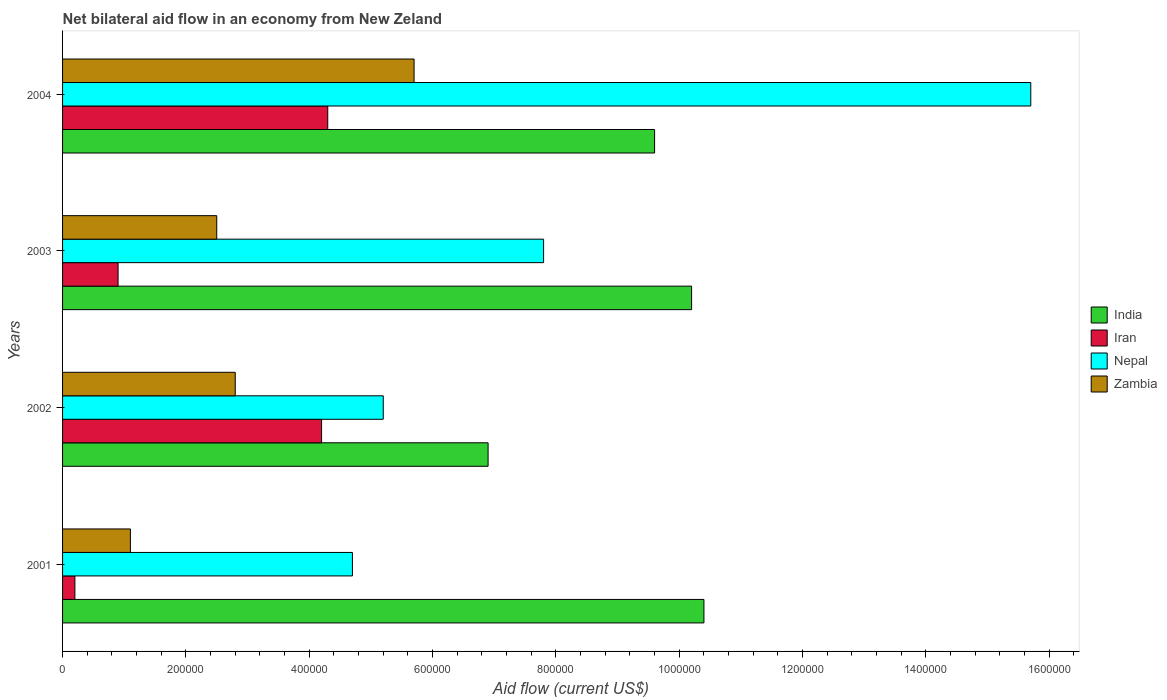Are the number of bars per tick equal to the number of legend labels?
Provide a short and direct response. Yes. In how many cases, is the number of bars for a given year not equal to the number of legend labels?
Offer a terse response. 0. What is the net bilateral aid flow in Iran in 2001?
Give a very brief answer. 2.00e+04. Across all years, what is the maximum net bilateral aid flow in Iran?
Make the answer very short. 4.30e+05. Across all years, what is the minimum net bilateral aid flow in Zambia?
Your answer should be compact. 1.10e+05. In which year was the net bilateral aid flow in Zambia maximum?
Your answer should be very brief. 2004. What is the total net bilateral aid flow in Zambia in the graph?
Keep it short and to the point. 1.21e+06. What is the difference between the net bilateral aid flow in Zambia in 2001 and the net bilateral aid flow in India in 2002?
Provide a succinct answer. -5.80e+05. What is the average net bilateral aid flow in Nepal per year?
Your answer should be very brief. 8.35e+05. In the year 2003, what is the difference between the net bilateral aid flow in Iran and net bilateral aid flow in Nepal?
Give a very brief answer. -6.90e+05. What is the ratio of the net bilateral aid flow in Nepal in 2001 to that in 2004?
Your answer should be very brief. 0.3. What is the difference between the highest and the second highest net bilateral aid flow in Zambia?
Keep it short and to the point. 2.90e+05. Is it the case that in every year, the sum of the net bilateral aid flow in India and net bilateral aid flow in Zambia is greater than the sum of net bilateral aid flow in Nepal and net bilateral aid flow in Iran?
Offer a terse response. No. What does the 3rd bar from the top in 2002 represents?
Your response must be concise. Iran. How many years are there in the graph?
Provide a succinct answer. 4. Where does the legend appear in the graph?
Ensure brevity in your answer.  Center right. How many legend labels are there?
Provide a succinct answer. 4. What is the title of the graph?
Offer a very short reply. Net bilateral aid flow in an economy from New Zeland. What is the label or title of the X-axis?
Your response must be concise. Aid flow (current US$). What is the label or title of the Y-axis?
Make the answer very short. Years. What is the Aid flow (current US$) of India in 2001?
Your answer should be very brief. 1.04e+06. What is the Aid flow (current US$) in Iran in 2001?
Provide a short and direct response. 2.00e+04. What is the Aid flow (current US$) in India in 2002?
Keep it short and to the point. 6.90e+05. What is the Aid flow (current US$) of Iran in 2002?
Offer a very short reply. 4.20e+05. What is the Aid flow (current US$) of Nepal in 2002?
Your answer should be very brief. 5.20e+05. What is the Aid flow (current US$) in Zambia in 2002?
Make the answer very short. 2.80e+05. What is the Aid flow (current US$) in India in 2003?
Make the answer very short. 1.02e+06. What is the Aid flow (current US$) of Nepal in 2003?
Give a very brief answer. 7.80e+05. What is the Aid flow (current US$) in Zambia in 2003?
Provide a short and direct response. 2.50e+05. What is the Aid flow (current US$) of India in 2004?
Your answer should be very brief. 9.60e+05. What is the Aid flow (current US$) of Iran in 2004?
Your answer should be very brief. 4.30e+05. What is the Aid flow (current US$) in Nepal in 2004?
Provide a short and direct response. 1.57e+06. What is the Aid flow (current US$) of Zambia in 2004?
Offer a terse response. 5.70e+05. Across all years, what is the maximum Aid flow (current US$) of India?
Make the answer very short. 1.04e+06. Across all years, what is the maximum Aid flow (current US$) in Iran?
Provide a short and direct response. 4.30e+05. Across all years, what is the maximum Aid flow (current US$) in Nepal?
Offer a terse response. 1.57e+06. Across all years, what is the maximum Aid flow (current US$) of Zambia?
Offer a terse response. 5.70e+05. Across all years, what is the minimum Aid flow (current US$) of India?
Ensure brevity in your answer.  6.90e+05. Across all years, what is the minimum Aid flow (current US$) of Iran?
Keep it short and to the point. 2.00e+04. Across all years, what is the minimum Aid flow (current US$) in Zambia?
Keep it short and to the point. 1.10e+05. What is the total Aid flow (current US$) of India in the graph?
Make the answer very short. 3.71e+06. What is the total Aid flow (current US$) in Iran in the graph?
Provide a short and direct response. 9.60e+05. What is the total Aid flow (current US$) in Nepal in the graph?
Your response must be concise. 3.34e+06. What is the total Aid flow (current US$) of Zambia in the graph?
Provide a short and direct response. 1.21e+06. What is the difference between the Aid flow (current US$) of India in 2001 and that in 2002?
Your response must be concise. 3.50e+05. What is the difference between the Aid flow (current US$) of Iran in 2001 and that in 2002?
Your answer should be very brief. -4.00e+05. What is the difference between the Aid flow (current US$) of Nepal in 2001 and that in 2002?
Offer a terse response. -5.00e+04. What is the difference between the Aid flow (current US$) of India in 2001 and that in 2003?
Ensure brevity in your answer.  2.00e+04. What is the difference between the Aid flow (current US$) in Nepal in 2001 and that in 2003?
Give a very brief answer. -3.10e+05. What is the difference between the Aid flow (current US$) of Iran in 2001 and that in 2004?
Provide a short and direct response. -4.10e+05. What is the difference between the Aid flow (current US$) in Nepal in 2001 and that in 2004?
Provide a short and direct response. -1.10e+06. What is the difference between the Aid flow (current US$) of Zambia in 2001 and that in 2004?
Your response must be concise. -4.60e+05. What is the difference between the Aid flow (current US$) in India in 2002 and that in 2003?
Give a very brief answer. -3.30e+05. What is the difference between the Aid flow (current US$) in Iran in 2002 and that in 2003?
Your answer should be very brief. 3.30e+05. What is the difference between the Aid flow (current US$) in Zambia in 2002 and that in 2003?
Keep it short and to the point. 3.00e+04. What is the difference between the Aid flow (current US$) in India in 2002 and that in 2004?
Your response must be concise. -2.70e+05. What is the difference between the Aid flow (current US$) in Nepal in 2002 and that in 2004?
Make the answer very short. -1.05e+06. What is the difference between the Aid flow (current US$) in Iran in 2003 and that in 2004?
Your answer should be compact. -3.40e+05. What is the difference between the Aid flow (current US$) of Nepal in 2003 and that in 2004?
Your response must be concise. -7.90e+05. What is the difference between the Aid flow (current US$) in Zambia in 2003 and that in 2004?
Your answer should be very brief. -3.20e+05. What is the difference between the Aid flow (current US$) of India in 2001 and the Aid flow (current US$) of Iran in 2002?
Offer a very short reply. 6.20e+05. What is the difference between the Aid flow (current US$) of India in 2001 and the Aid flow (current US$) of Nepal in 2002?
Offer a very short reply. 5.20e+05. What is the difference between the Aid flow (current US$) in India in 2001 and the Aid flow (current US$) in Zambia in 2002?
Your answer should be compact. 7.60e+05. What is the difference between the Aid flow (current US$) in Iran in 2001 and the Aid flow (current US$) in Nepal in 2002?
Make the answer very short. -5.00e+05. What is the difference between the Aid flow (current US$) in Iran in 2001 and the Aid flow (current US$) in Zambia in 2002?
Your answer should be very brief. -2.60e+05. What is the difference between the Aid flow (current US$) of India in 2001 and the Aid flow (current US$) of Iran in 2003?
Offer a very short reply. 9.50e+05. What is the difference between the Aid flow (current US$) of India in 2001 and the Aid flow (current US$) of Nepal in 2003?
Your response must be concise. 2.60e+05. What is the difference between the Aid flow (current US$) in India in 2001 and the Aid flow (current US$) in Zambia in 2003?
Your response must be concise. 7.90e+05. What is the difference between the Aid flow (current US$) of Iran in 2001 and the Aid flow (current US$) of Nepal in 2003?
Provide a short and direct response. -7.60e+05. What is the difference between the Aid flow (current US$) of Iran in 2001 and the Aid flow (current US$) of Zambia in 2003?
Make the answer very short. -2.30e+05. What is the difference between the Aid flow (current US$) in Nepal in 2001 and the Aid flow (current US$) in Zambia in 2003?
Provide a succinct answer. 2.20e+05. What is the difference between the Aid flow (current US$) in India in 2001 and the Aid flow (current US$) in Iran in 2004?
Your response must be concise. 6.10e+05. What is the difference between the Aid flow (current US$) in India in 2001 and the Aid flow (current US$) in Nepal in 2004?
Your answer should be very brief. -5.30e+05. What is the difference between the Aid flow (current US$) of India in 2001 and the Aid flow (current US$) of Zambia in 2004?
Keep it short and to the point. 4.70e+05. What is the difference between the Aid flow (current US$) in Iran in 2001 and the Aid flow (current US$) in Nepal in 2004?
Your answer should be very brief. -1.55e+06. What is the difference between the Aid flow (current US$) of Iran in 2001 and the Aid flow (current US$) of Zambia in 2004?
Provide a short and direct response. -5.50e+05. What is the difference between the Aid flow (current US$) in India in 2002 and the Aid flow (current US$) in Nepal in 2003?
Your answer should be very brief. -9.00e+04. What is the difference between the Aid flow (current US$) of India in 2002 and the Aid flow (current US$) of Zambia in 2003?
Your answer should be very brief. 4.40e+05. What is the difference between the Aid flow (current US$) of Iran in 2002 and the Aid flow (current US$) of Nepal in 2003?
Your answer should be very brief. -3.60e+05. What is the difference between the Aid flow (current US$) of Iran in 2002 and the Aid flow (current US$) of Zambia in 2003?
Your response must be concise. 1.70e+05. What is the difference between the Aid flow (current US$) of India in 2002 and the Aid flow (current US$) of Nepal in 2004?
Your answer should be compact. -8.80e+05. What is the difference between the Aid flow (current US$) in Iran in 2002 and the Aid flow (current US$) in Nepal in 2004?
Your answer should be very brief. -1.15e+06. What is the difference between the Aid flow (current US$) of Iran in 2002 and the Aid flow (current US$) of Zambia in 2004?
Provide a succinct answer. -1.50e+05. What is the difference between the Aid flow (current US$) of India in 2003 and the Aid flow (current US$) of Iran in 2004?
Your answer should be very brief. 5.90e+05. What is the difference between the Aid flow (current US$) of India in 2003 and the Aid flow (current US$) of Nepal in 2004?
Make the answer very short. -5.50e+05. What is the difference between the Aid flow (current US$) of Iran in 2003 and the Aid flow (current US$) of Nepal in 2004?
Your response must be concise. -1.48e+06. What is the difference between the Aid flow (current US$) of Iran in 2003 and the Aid flow (current US$) of Zambia in 2004?
Make the answer very short. -4.80e+05. What is the difference between the Aid flow (current US$) of Nepal in 2003 and the Aid flow (current US$) of Zambia in 2004?
Make the answer very short. 2.10e+05. What is the average Aid flow (current US$) of India per year?
Your answer should be compact. 9.28e+05. What is the average Aid flow (current US$) of Nepal per year?
Offer a terse response. 8.35e+05. What is the average Aid flow (current US$) in Zambia per year?
Give a very brief answer. 3.02e+05. In the year 2001, what is the difference between the Aid flow (current US$) in India and Aid flow (current US$) in Iran?
Ensure brevity in your answer.  1.02e+06. In the year 2001, what is the difference between the Aid flow (current US$) in India and Aid flow (current US$) in Nepal?
Offer a terse response. 5.70e+05. In the year 2001, what is the difference between the Aid flow (current US$) of India and Aid flow (current US$) of Zambia?
Provide a short and direct response. 9.30e+05. In the year 2001, what is the difference between the Aid flow (current US$) of Iran and Aid flow (current US$) of Nepal?
Keep it short and to the point. -4.50e+05. In the year 2001, what is the difference between the Aid flow (current US$) of Nepal and Aid flow (current US$) of Zambia?
Ensure brevity in your answer.  3.60e+05. In the year 2002, what is the difference between the Aid flow (current US$) in India and Aid flow (current US$) in Iran?
Offer a very short reply. 2.70e+05. In the year 2003, what is the difference between the Aid flow (current US$) in India and Aid flow (current US$) in Iran?
Your response must be concise. 9.30e+05. In the year 2003, what is the difference between the Aid flow (current US$) in India and Aid flow (current US$) in Zambia?
Your response must be concise. 7.70e+05. In the year 2003, what is the difference between the Aid flow (current US$) in Iran and Aid flow (current US$) in Nepal?
Offer a terse response. -6.90e+05. In the year 2003, what is the difference between the Aid flow (current US$) of Iran and Aid flow (current US$) of Zambia?
Provide a succinct answer. -1.60e+05. In the year 2003, what is the difference between the Aid flow (current US$) in Nepal and Aid flow (current US$) in Zambia?
Your response must be concise. 5.30e+05. In the year 2004, what is the difference between the Aid flow (current US$) in India and Aid flow (current US$) in Iran?
Offer a very short reply. 5.30e+05. In the year 2004, what is the difference between the Aid flow (current US$) in India and Aid flow (current US$) in Nepal?
Your response must be concise. -6.10e+05. In the year 2004, what is the difference between the Aid flow (current US$) of Iran and Aid flow (current US$) of Nepal?
Your response must be concise. -1.14e+06. In the year 2004, what is the difference between the Aid flow (current US$) in Iran and Aid flow (current US$) in Zambia?
Provide a short and direct response. -1.40e+05. In the year 2004, what is the difference between the Aid flow (current US$) of Nepal and Aid flow (current US$) of Zambia?
Make the answer very short. 1.00e+06. What is the ratio of the Aid flow (current US$) in India in 2001 to that in 2002?
Give a very brief answer. 1.51. What is the ratio of the Aid flow (current US$) of Iran in 2001 to that in 2002?
Make the answer very short. 0.05. What is the ratio of the Aid flow (current US$) of Nepal in 2001 to that in 2002?
Your answer should be compact. 0.9. What is the ratio of the Aid flow (current US$) of Zambia in 2001 to that in 2002?
Your answer should be very brief. 0.39. What is the ratio of the Aid flow (current US$) in India in 2001 to that in 2003?
Offer a very short reply. 1.02. What is the ratio of the Aid flow (current US$) in Iran in 2001 to that in 2003?
Make the answer very short. 0.22. What is the ratio of the Aid flow (current US$) of Nepal in 2001 to that in 2003?
Offer a very short reply. 0.6. What is the ratio of the Aid flow (current US$) of Zambia in 2001 to that in 2003?
Offer a very short reply. 0.44. What is the ratio of the Aid flow (current US$) of India in 2001 to that in 2004?
Ensure brevity in your answer.  1.08. What is the ratio of the Aid flow (current US$) of Iran in 2001 to that in 2004?
Provide a short and direct response. 0.05. What is the ratio of the Aid flow (current US$) in Nepal in 2001 to that in 2004?
Make the answer very short. 0.3. What is the ratio of the Aid flow (current US$) in Zambia in 2001 to that in 2004?
Ensure brevity in your answer.  0.19. What is the ratio of the Aid flow (current US$) in India in 2002 to that in 2003?
Your answer should be very brief. 0.68. What is the ratio of the Aid flow (current US$) of Iran in 2002 to that in 2003?
Provide a succinct answer. 4.67. What is the ratio of the Aid flow (current US$) of Zambia in 2002 to that in 2003?
Give a very brief answer. 1.12. What is the ratio of the Aid flow (current US$) in India in 2002 to that in 2004?
Provide a succinct answer. 0.72. What is the ratio of the Aid flow (current US$) of Iran in 2002 to that in 2004?
Provide a short and direct response. 0.98. What is the ratio of the Aid flow (current US$) of Nepal in 2002 to that in 2004?
Provide a short and direct response. 0.33. What is the ratio of the Aid flow (current US$) of Zambia in 2002 to that in 2004?
Make the answer very short. 0.49. What is the ratio of the Aid flow (current US$) of Iran in 2003 to that in 2004?
Offer a terse response. 0.21. What is the ratio of the Aid flow (current US$) of Nepal in 2003 to that in 2004?
Make the answer very short. 0.5. What is the ratio of the Aid flow (current US$) of Zambia in 2003 to that in 2004?
Your answer should be compact. 0.44. What is the difference between the highest and the second highest Aid flow (current US$) of India?
Make the answer very short. 2.00e+04. What is the difference between the highest and the second highest Aid flow (current US$) in Nepal?
Make the answer very short. 7.90e+05. What is the difference between the highest and the lowest Aid flow (current US$) in Iran?
Your response must be concise. 4.10e+05. What is the difference between the highest and the lowest Aid flow (current US$) in Nepal?
Offer a very short reply. 1.10e+06. What is the difference between the highest and the lowest Aid flow (current US$) in Zambia?
Ensure brevity in your answer.  4.60e+05. 